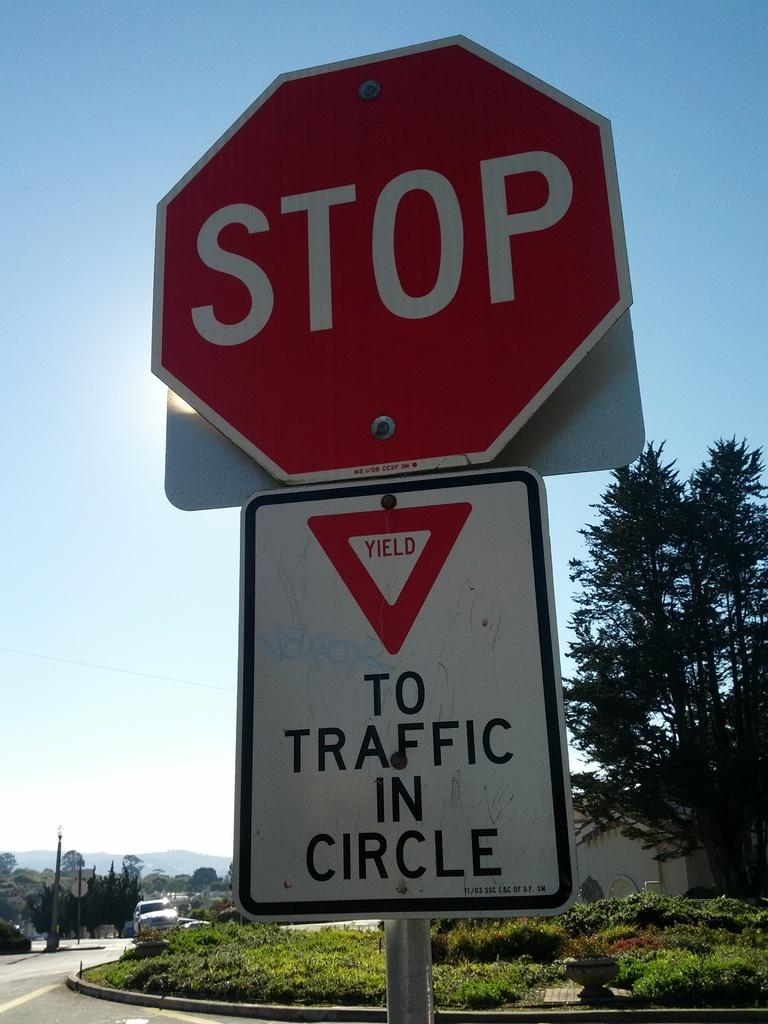<image>
Describe the image concisely. Stop and Yield sign together warning drivers to stop and yield to traffic in circle. 